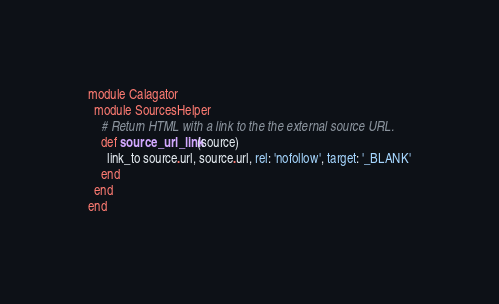<code> <loc_0><loc_0><loc_500><loc_500><_Ruby_>module Calagator
  module SourcesHelper
    # Return HTML with a link to the the external source URL.
    def source_url_link(source)
      link_to source.url, source.url, rel: 'nofollow', target: '_BLANK'
    end
  end
end
</code> 